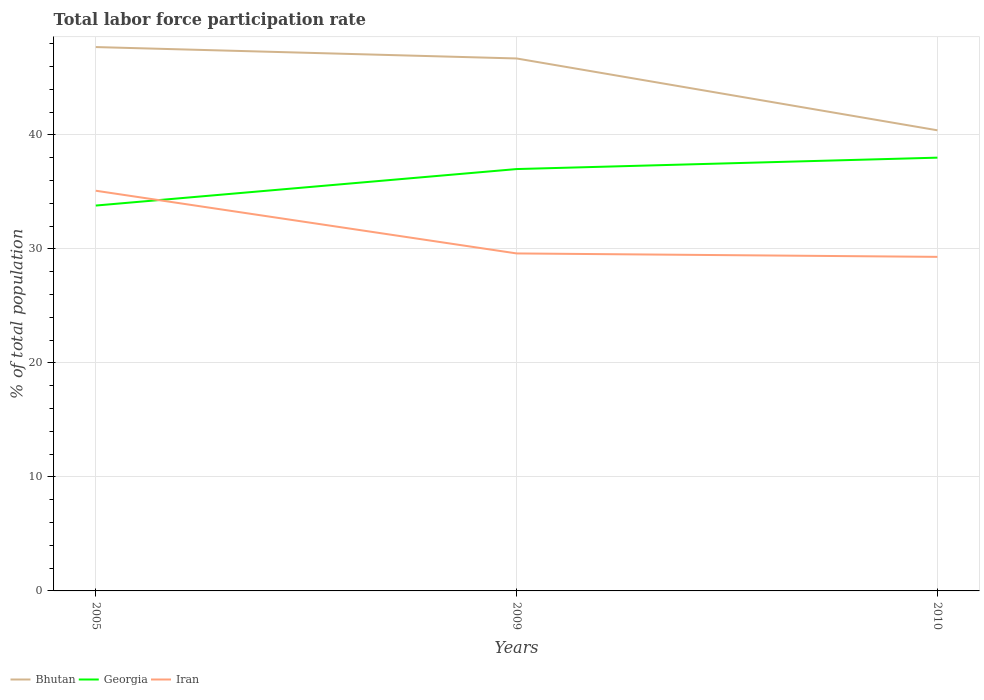How many different coloured lines are there?
Your answer should be very brief. 3. Does the line corresponding to Bhutan intersect with the line corresponding to Georgia?
Give a very brief answer. No. Is the number of lines equal to the number of legend labels?
Your answer should be compact. Yes. Across all years, what is the maximum total labor force participation rate in Iran?
Your answer should be very brief. 29.3. What is the total total labor force participation rate in Bhutan in the graph?
Keep it short and to the point. 6.3. What is the difference between the highest and the second highest total labor force participation rate in Iran?
Ensure brevity in your answer.  5.8. What is the difference between the highest and the lowest total labor force participation rate in Georgia?
Ensure brevity in your answer.  2. Is the total labor force participation rate in Georgia strictly greater than the total labor force participation rate in Bhutan over the years?
Your answer should be compact. Yes. How many lines are there?
Offer a terse response. 3. How many years are there in the graph?
Make the answer very short. 3. Does the graph contain any zero values?
Ensure brevity in your answer.  No. Does the graph contain grids?
Provide a succinct answer. Yes. Where does the legend appear in the graph?
Provide a succinct answer. Bottom left. How many legend labels are there?
Your answer should be very brief. 3. What is the title of the graph?
Your response must be concise. Total labor force participation rate. What is the label or title of the X-axis?
Offer a terse response. Years. What is the label or title of the Y-axis?
Provide a succinct answer. % of total population. What is the % of total population in Bhutan in 2005?
Your response must be concise. 47.7. What is the % of total population in Georgia in 2005?
Your response must be concise. 33.8. What is the % of total population in Iran in 2005?
Your response must be concise. 35.1. What is the % of total population in Bhutan in 2009?
Provide a short and direct response. 46.7. What is the % of total population in Georgia in 2009?
Ensure brevity in your answer.  37. What is the % of total population in Iran in 2009?
Provide a succinct answer. 29.6. What is the % of total population in Bhutan in 2010?
Provide a succinct answer. 40.4. What is the % of total population of Iran in 2010?
Make the answer very short. 29.3. Across all years, what is the maximum % of total population of Bhutan?
Keep it short and to the point. 47.7. Across all years, what is the maximum % of total population in Georgia?
Your answer should be very brief. 38. Across all years, what is the maximum % of total population in Iran?
Your response must be concise. 35.1. Across all years, what is the minimum % of total population of Bhutan?
Offer a terse response. 40.4. Across all years, what is the minimum % of total population in Georgia?
Ensure brevity in your answer.  33.8. Across all years, what is the minimum % of total population of Iran?
Your answer should be compact. 29.3. What is the total % of total population in Bhutan in the graph?
Your answer should be very brief. 134.8. What is the total % of total population of Georgia in the graph?
Your answer should be compact. 108.8. What is the total % of total population of Iran in the graph?
Your answer should be compact. 94. What is the difference between the % of total population of Bhutan in 2005 and that in 2009?
Your response must be concise. 1. What is the difference between the % of total population of Georgia in 2005 and that in 2009?
Provide a succinct answer. -3.2. What is the difference between the % of total population in Bhutan in 2005 and that in 2010?
Make the answer very short. 7.3. What is the difference between the % of total population of Georgia in 2005 and that in 2010?
Make the answer very short. -4.2. What is the difference between the % of total population of Georgia in 2009 and that in 2010?
Keep it short and to the point. -1. What is the difference between the % of total population of Bhutan in 2005 and the % of total population of Georgia in 2009?
Make the answer very short. 10.7. What is the difference between the % of total population of Bhutan in 2005 and the % of total population of Iran in 2010?
Make the answer very short. 18.4. What is the difference between the % of total population of Bhutan in 2009 and the % of total population of Iran in 2010?
Make the answer very short. 17.4. What is the average % of total population in Bhutan per year?
Keep it short and to the point. 44.93. What is the average % of total population of Georgia per year?
Offer a terse response. 36.27. What is the average % of total population in Iran per year?
Ensure brevity in your answer.  31.33. In the year 2005, what is the difference between the % of total population in Bhutan and % of total population in Iran?
Provide a short and direct response. 12.6. In the year 2005, what is the difference between the % of total population of Georgia and % of total population of Iran?
Your answer should be compact. -1.3. In the year 2009, what is the difference between the % of total population of Georgia and % of total population of Iran?
Your answer should be very brief. 7.4. In the year 2010, what is the difference between the % of total population in Bhutan and % of total population in Georgia?
Ensure brevity in your answer.  2.4. In the year 2010, what is the difference between the % of total population in Georgia and % of total population in Iran?
Provide a short and direct response. 8.7. What is the ratio of the % of total population of Bhutan in 2005 to that in 2009?
Make the answer very short. 1.02. What is the ratio of the % of total population of Georgia in 2005 to that in 2009?
Make the answer very short. 0.91. What is the ratio of the % of total population in Iran in 2005 to that in 2009?
Provide a short and direct response. 1.19. What is the ratio of the % of total population of Bhutan in 2005 to that in 2010?
Provide a succinct answer. 1.18. What is the ratio of the % of total population of Georgia in 2005 to that in 2010?
Offer a very short reply. 0.89. What is the ratio of the % of total population in Iran in 2005 to that in 2010?
Make the answer very short. 1.2. What is the ratio of the % of total population in Bhutan in 2009 to that in 2010?
Make the answer very short. 1.16. What is the ratio of the % of total population of Georgia in 2009 to that in 2010?
Offer a terse response. 0.97. What is the ratio of the % of total population in Iran in 2009 to that in 2010?
Provide a succinct answer. 1.01. What is the difference between the highest and the second highest % of total population of Georgia?
Keep it short and to the point. 1. What is the difference between the highest and the second highest % of total population of Iran?
Make the answer very short. 5.5. What is the difference between the highest and the lowest % of total population in Bhutan?
Keep it short and to the point. 7.3. What is the difference between the highest and the lowest % of total population of Georgia?
Make the answer very short. 4.2. What is the difference between the highest and the lowest % of total population in Iran?
Ensure brevity in your answer.  5.8. 